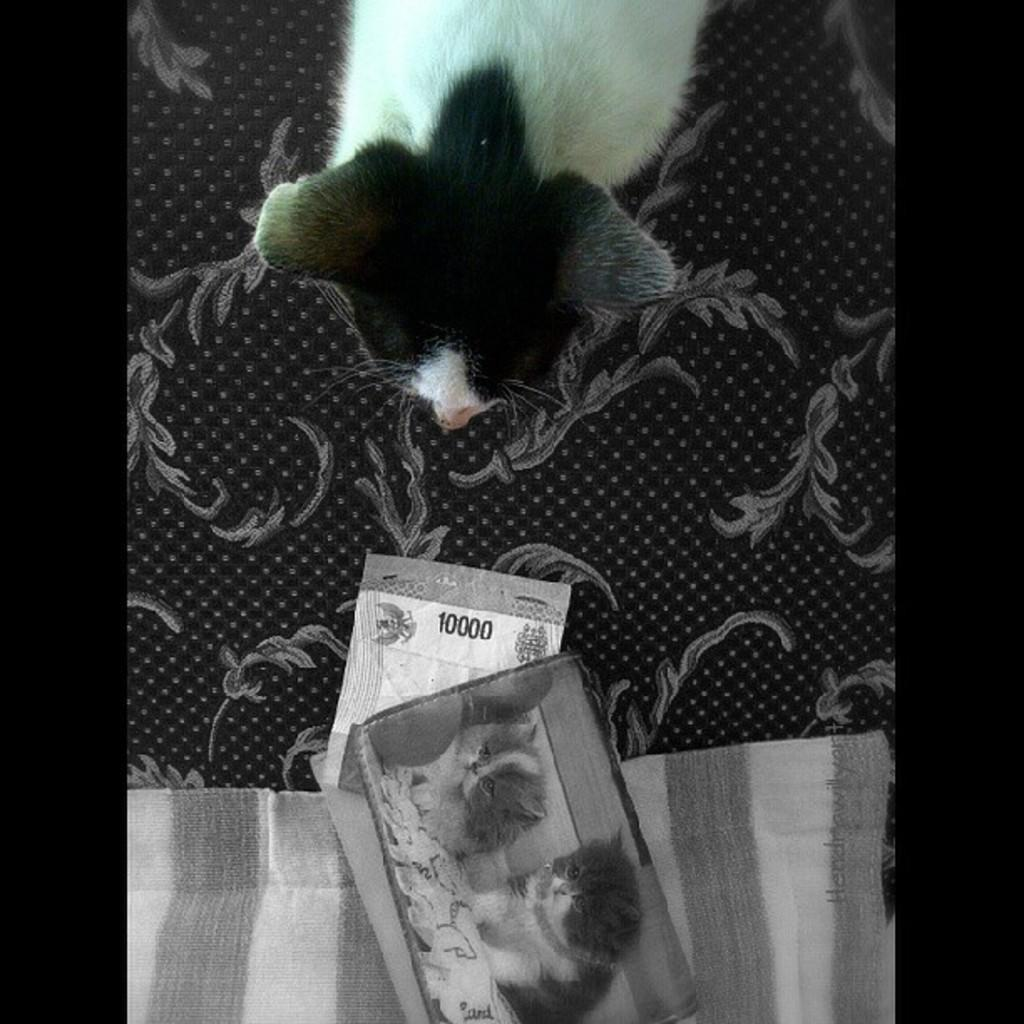What is in the foreground of the image? There are pictures of two kittens in the foreground of the image. What are the pictures placed on? The pictures are on an object. Can you describe the material visible in the image? There is cloth visible in the image. What can be seen at the top of the image? There is an animal and other objects at the top of the image. What type of machine is used to create the boundary in the image? There is no machine or boundary present in the image. 